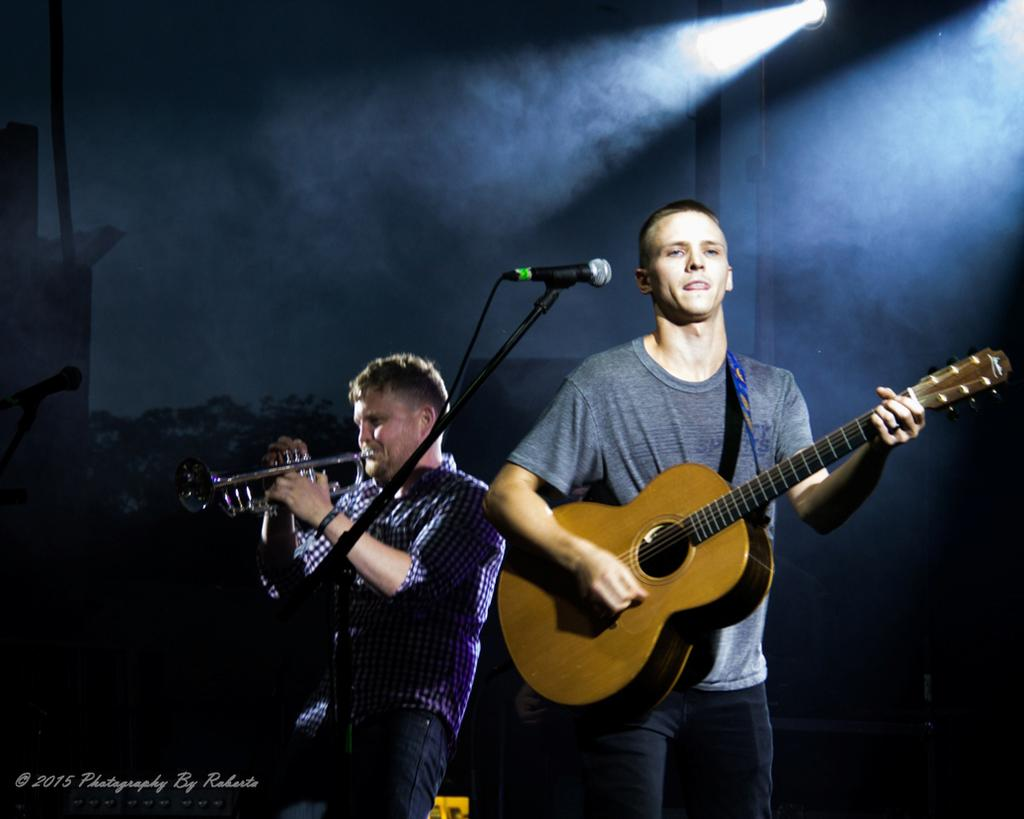How many people are in the image? There are two men in the image. What are the men doing in the image? One man is playing a guitar and singing into a microphone, while the other man is playing a trumpet. What can be seen in the background of the image? There is a wall, a light, and trees in the background of the image. Can you see any bubbles floating around the men in the image? No, there are no bubbles present in the image. Are there any deer visible in the background of the image? No, there are no deer present in the image; only trees can be seen in the background. 